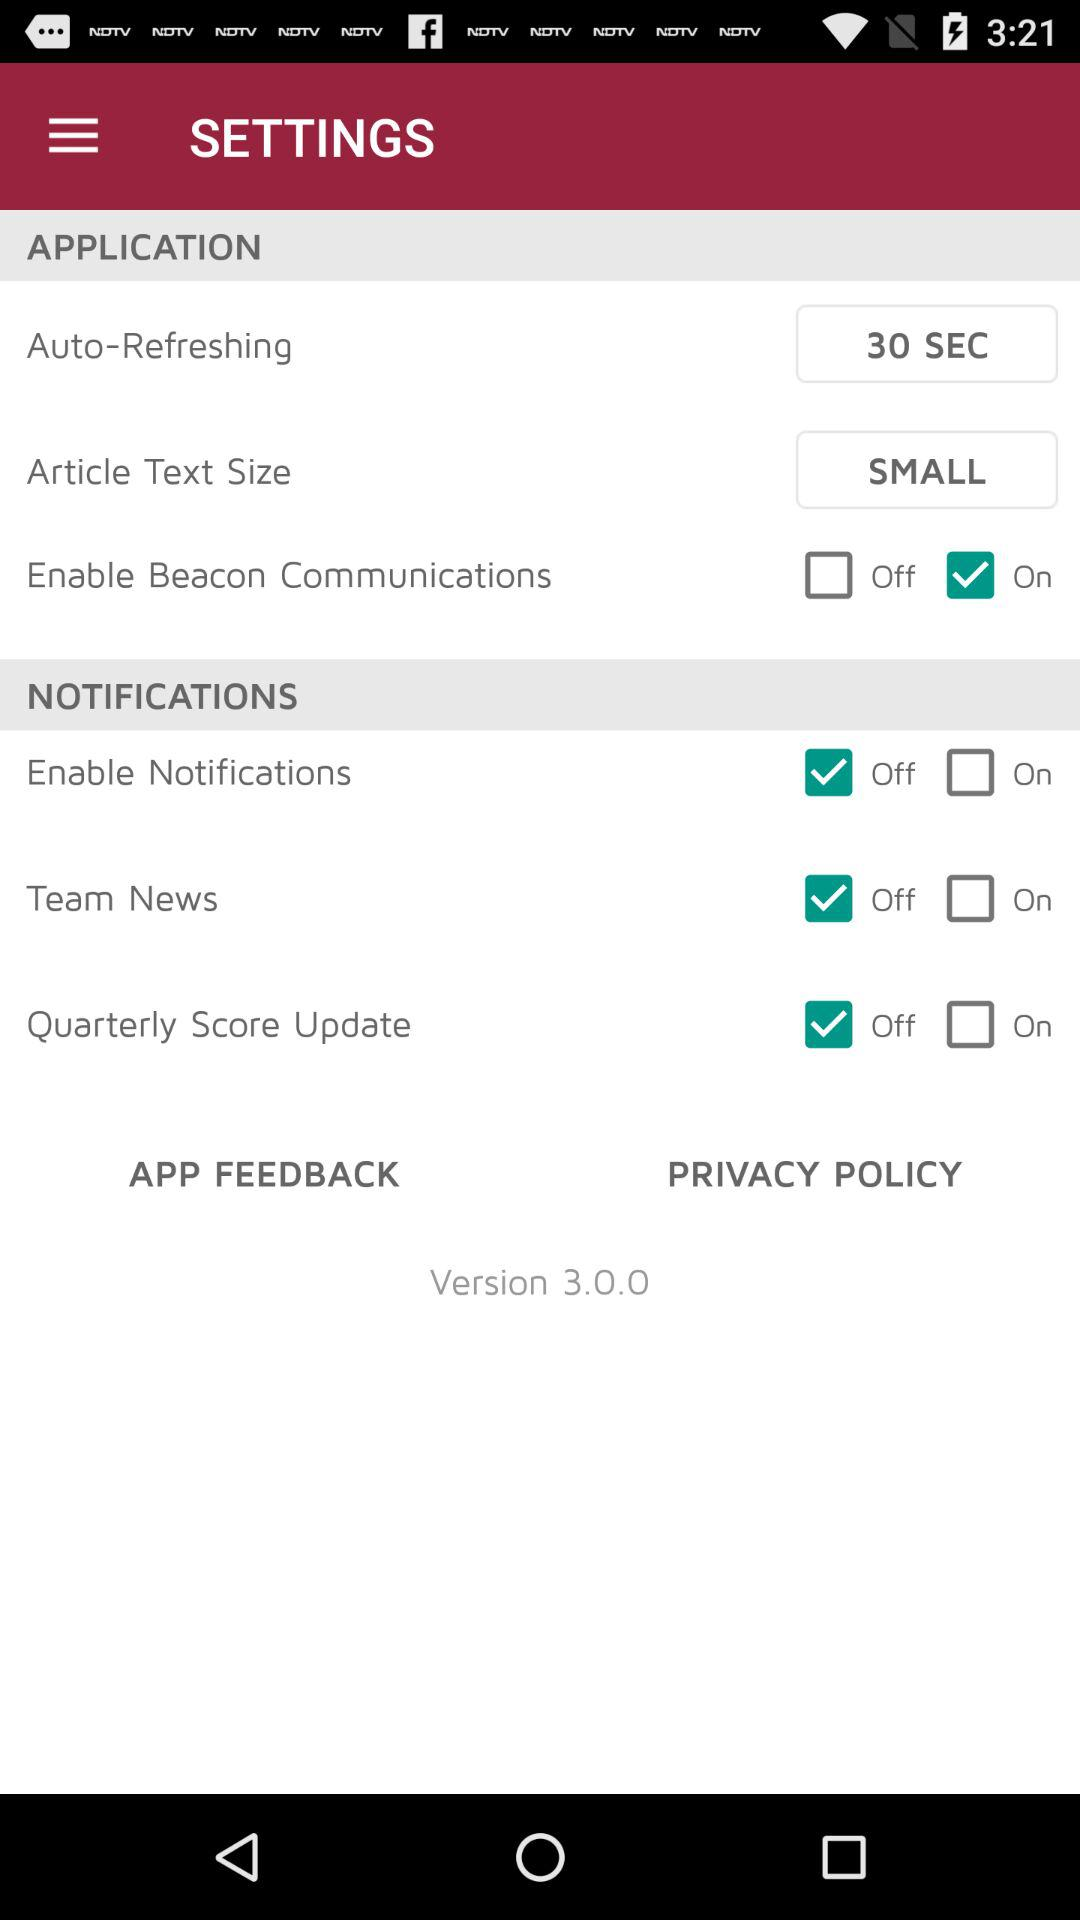What is the setting for the "Quarterly Score Update"? The setting for the "Quarterly Score Update" is "Off". 